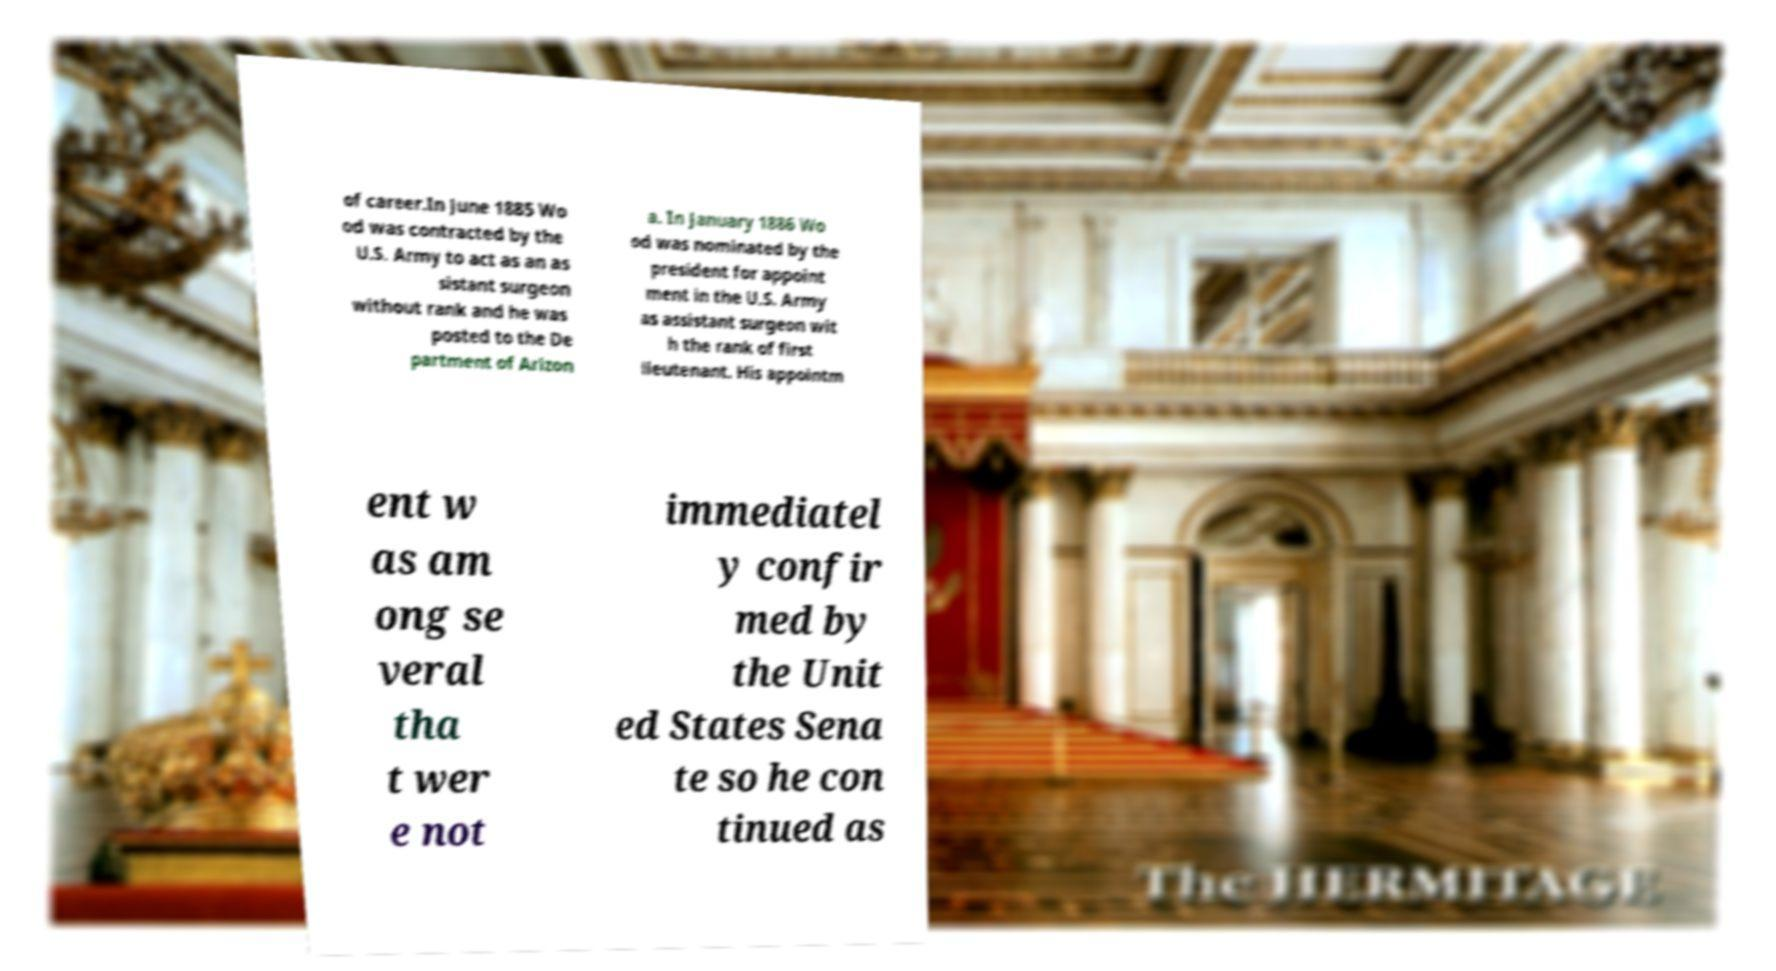Please identify and transcribe the text found in this image. of career.In June 1885 Wo od was contracted by the U.S. Army to act as an as sistant surgeon without rank and he was posted to the De partment of Arizon a. In January 1886 Wo od was nominated by the president for appoint ment in the U.S. Army as assistant surgeon wit h the rank of first lieutenant. His appointm ent w as am ong se veral tha t wer e not immediatel y confir med by the Unit ed States Sena te so he con tinued as 